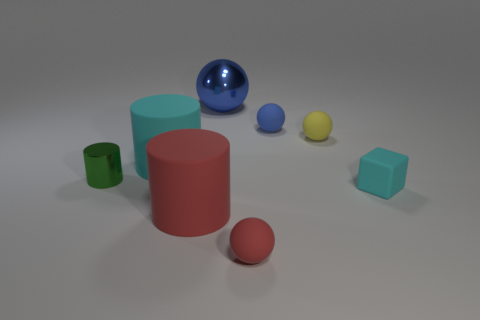Subtract all small yellow matte spheres. How many spheres are left? 3 Subtract all red cylinders. How many cylinders are left? 2 Subtract all cubes. How many objects are left? 7 Add 2 red rubber objects. How many objects exist? 10 Add 1 large matte objects. How many large matte objects are left? 3 Add 2 small red metal cubes. How many small red metal cubes exist? 2 Subtract 0 gray cylinders. How many objects are left? 8 Subtract 2 cylinders. How many cylinders are left? 1 Subtract all purple spheres. Subtract all red cylinders. How many spheres are left? 4 Subtract all green blocks. How many green cylinders are left? 1 